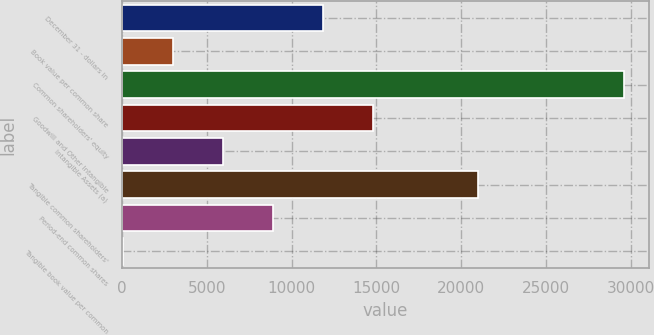Convert chart. <chart><loc_0><loc_0><loc_500><loc_500><bar_chart><fcel>December 31 - dollars in<fcel>Book value per common share<fcel>Common shareholders' equity<fcel>Goodwill and Other Intangible<fcel>Intangible Assets (a)<fcel>Tangible common shareholders'<fcel>Period-end common shares<fcel>Tangible book value per common<nl><fcel>11862.4<fcel>2995.54<fcel>29596<fcel>14818<fcel>5951.15<fcel>21005<fcel>8906.76<fcel>39.93<nl></chart> 